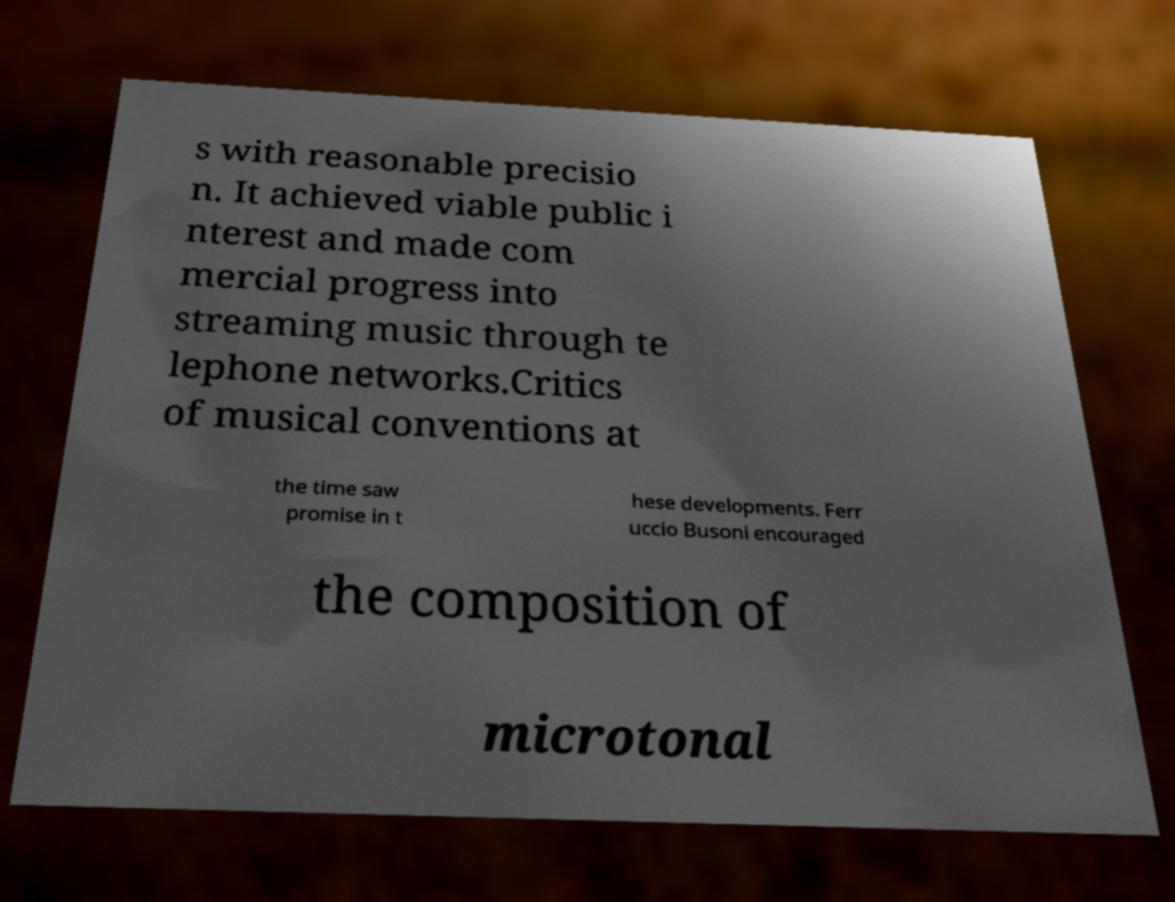What messages or text are displayed in this image? I need them in a readable, typed format. s with reasonable precisio n. It achieved viable public i nterest and made com mercial progress into streaming music through te lephone networks.Critics of musical conventions at the time saw promise in t hese developments. Ferr uccio Busoni encouraged the composition of microtonal 